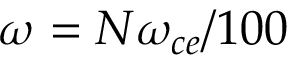Convert formula to latex. <formula><loc_0><loc_0><loc_500><loc_500>\omega = N \omega _ { c e } / 1 0 0</formula> 